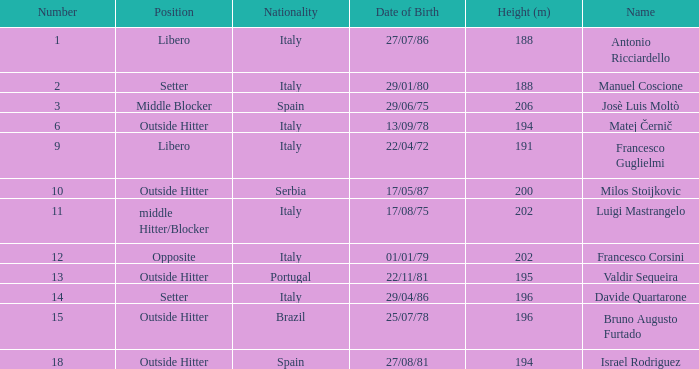Name the height for date of birth being 17/08/75 202.0. 